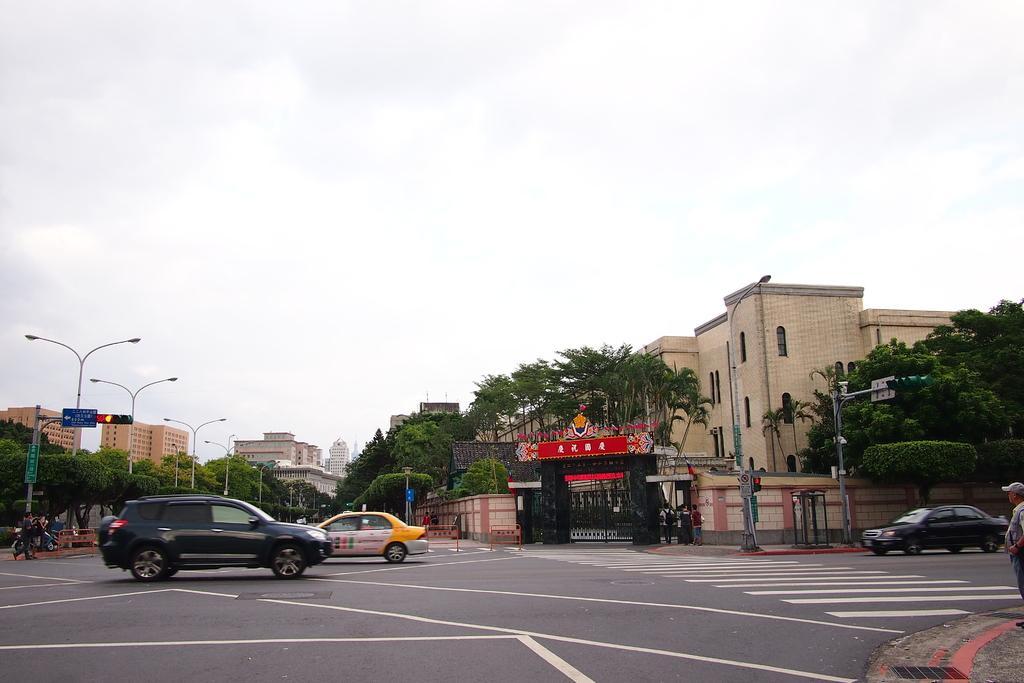How would you summarize this image in a sentence or two? In this image, we can see buildings, trees, walls, windows, traffic signals, boards, light poles and few objects. Here we can see vehicles and people. Background there is the sky. 